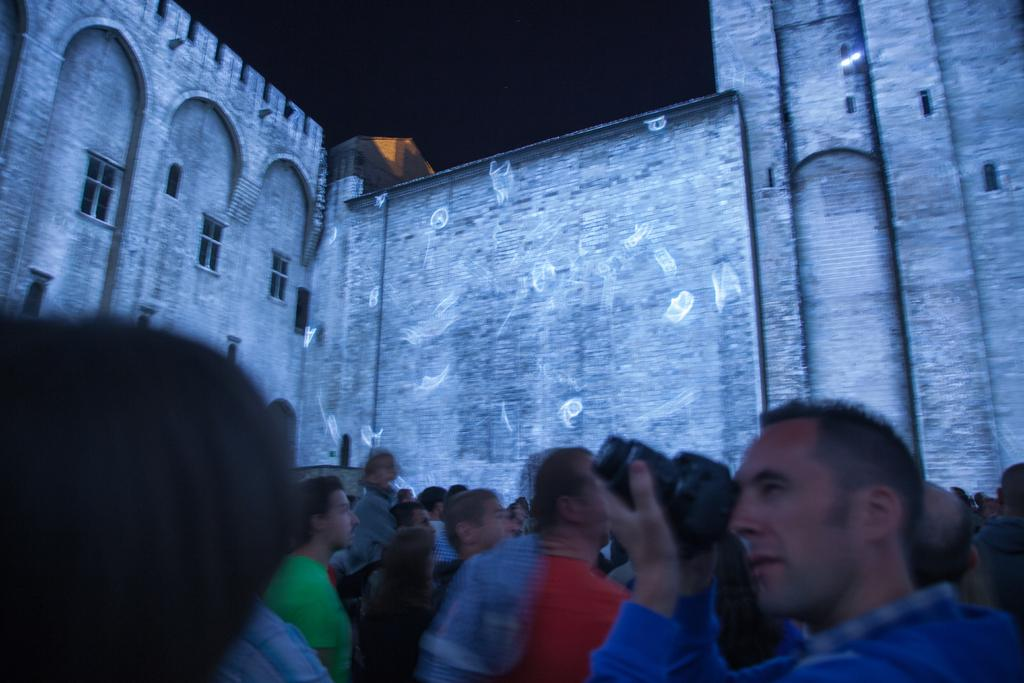How many people are in the image? There is a group of people in the image. What is one of the individuals doing in the image? A man is holding a camera in the image. What can be seen in the background of the image? There is a building depicted on the backside of the image. How many basketballs can be seen in the image? There are no basketballs present in the image. What type of wing is attached to the building in the image? There is no wing attached to the building in the image; it is a standalone structure. 